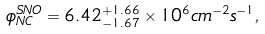<formula> <loc_0><loc_0><loc_500><loc_500>\phi _ { N C } ^ { S N O } = 6 . 4 2 _ { - 1 . 6 7 } ^ { + 1 . 6 6 } \times 1 0 ^ { 6 } c m ^ { - 2 } s ^ { - 1 } ,</formula> 